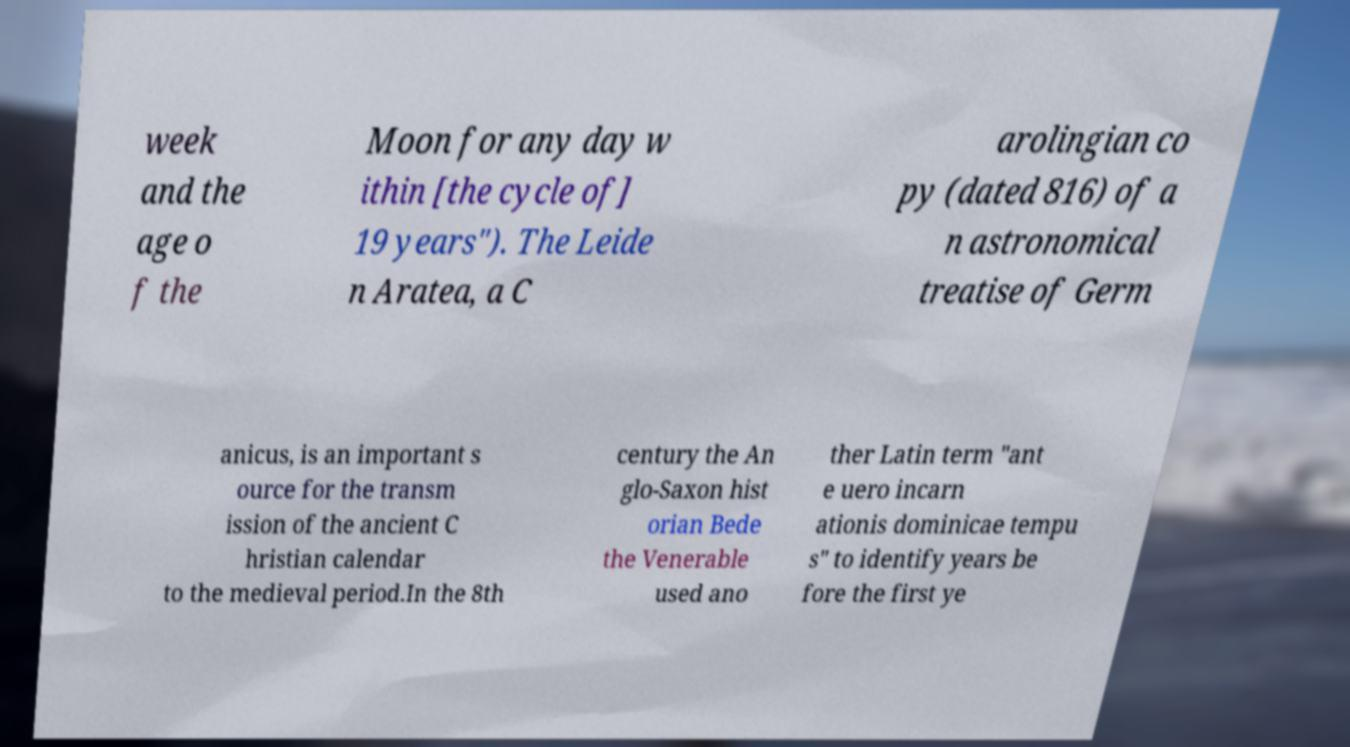Please identify and transcribe the text found in this image. week and the age o f the Moon for any day w ithin [the cycle of] 19 years"). The Leide n Aratea, a C arolingian co py (dated 816) of a n astronomical treatise of Germ anicus, is an important s ource for the transm ission of the ancient C hristian calendar to the medieval period.In the 8th century the An glo-Saxon hist orian Bede the Venerable used ano ther Latin term "ant e uero incarn ationis dominicae tempu s" to identify years be fore the first ye 